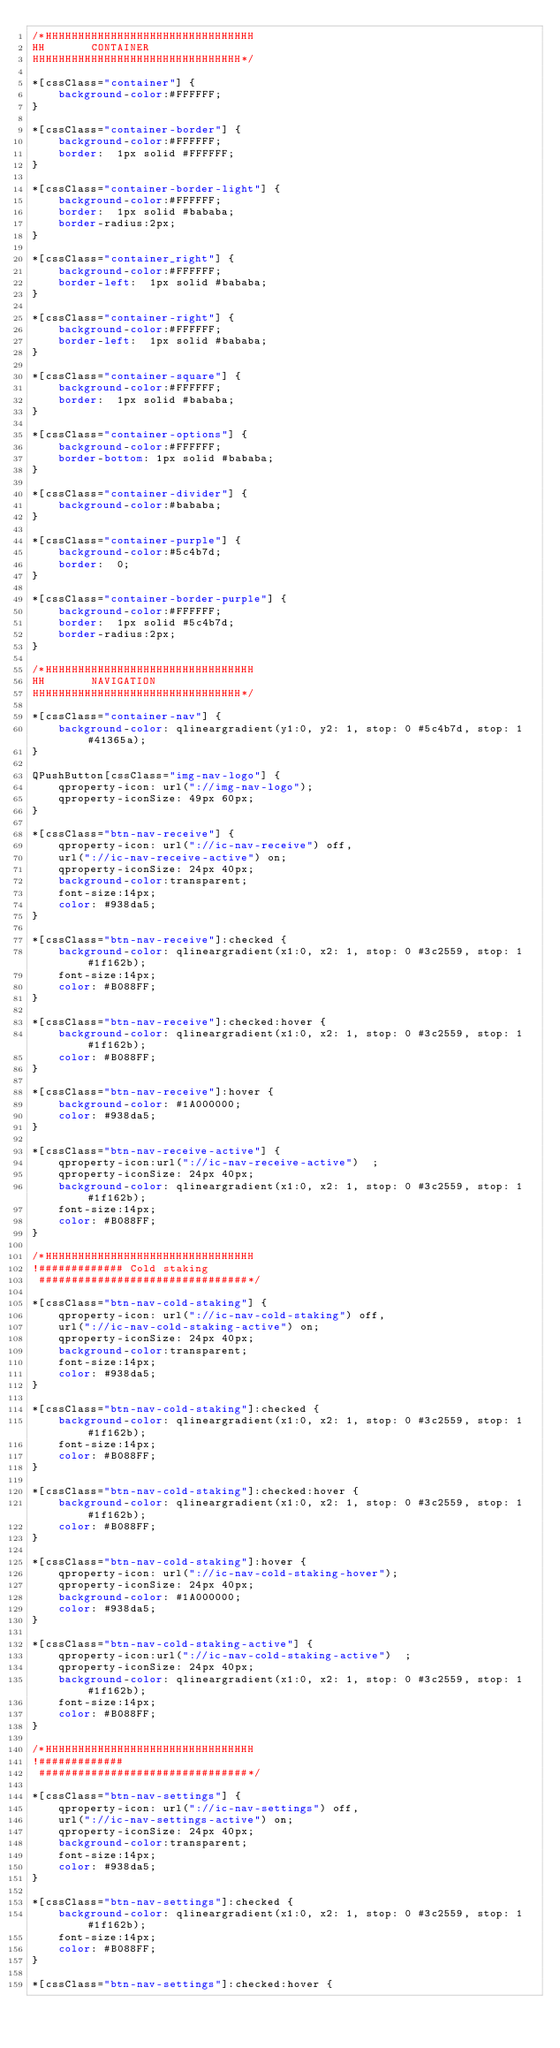<code> <loc_0><loc_0><loc_500><loc_500><_CSS_>/*HHHHHHHHHHHHHHHHHHHHHHHHHHHHHHHH
HH       CONTAINER
HHHHHHHHHHHHHHHHHHHHHHHHHHHHHHHH*/

*[cssClass="container"] {
    background-color:#FFFFFF;
}

*[cssClass="container-border"] {
    background-color:#FFFFFF;
    border:  1px solid #FFFFFF;
}

*[cssClass="container-border-light"] {
    background-color:#FFFFFF;
    border:  1px solid #bababa;
    border-radius:2px;
}

*[cssClass="container_right"] {
    background-color:#FFFFFF;
    border-left:  1px solid #bababa;
}

*[cssClass="container-right"] {
    background-color:#FFFFFF;
    border-left:  1px solid #bababa;
}

*[cssClass="container-square"] {
    background-color:#FFFFFF;
    border:  1px solid #bababa;
}

*[cssClass="container-options"] {
    background-color:#FFFFFF;
    border-bottom: 1px solid #bababa;
}

*[cssClass="container-divider"] {
    background-color:#bababa;
}

*[cssClass="container-purple"] {
    background-color:#5c4b7d;
    border:  0;
}

*[cssClass="container-border-purple"] {
    background-color:#FFFFFF;
    border:  1px solid #5c4b7d;
    border-radius:2px;
}

/*HHHHHHHHHHHHHHHHHHHHHHHHHHHHHHHH
HH       NAVIGATION
HHHHHHHHHHHHHHHHHHHHHHHHHHHHHHHH*/

*[cssClass="container-nav"] {
    background-color: qlineargradient(y1:0, y2: 1, stop: 0 #5c4b7d, stop: 1 #41365a);
}

QPushButton[cssClass="img-nav-logo"] {
    qproperty-icon: url("://img-nav-logo");
    qproperty-iconSize: 49px 60px;
}

*[cssClass="btn-nav-receive"] {
    qproperty-icon: url("://ic-nav-receive") off,
    url("://ic-nav-receive-active") on;
    qproperty-iconSize: 24px 40px;
    background-color:transparent;
    font-size:14px;
    color: #938da5;
}

*[cssClass="btn-nav-receive"]:checked {
    background-color: qlineargradient(x1:0, x2: 1, stop: 0 #3c2559, stop: 1 #1f162b);
    font-size:14px;
    color: #B088FF;
}

*[cssClass="btn-nav-receive"]:checked:hover {
    background-color: qlineargradient(x1:0, x2: 1, stop: 0 #3c2559, stop: 1 #1f162b);
    color: #B088FF;
}

*[cssClass="btn-nav-receive"]:hover {
    background-color: #1A000000;
    color: #938da5;
}

*[cssClass="btn-nav-receive-active"] {
    qproperty-icon:url("://ic-nav-receive-active")  ;
    qproperty-iconSize: 24px 40px;
    background-color: qlineargradient(x1:0, x2: 1, stop: 0 #3c2559, stop: 1 #1f162b);
    font-size:14px;
    color: #B088FF;
}

/*HHHHHHHHHHHHHHHHHHHHHHHHHHHHHHHH
!############# Cold staking
 ################################*/

*[cssClass="btn-nav-cold-staking"] {
    qproperty-icon: url("://ic-nav-cold-staking") off,
    url("://ic-nav-cold-staking-active") on;
    qproperty-iconSize: 24px 40px;
    background-color:transparent;
    font-size:14px;
    color: #938da5;
}

*[cssClass="btn-nav-cold-staking"]:checked {
    background-color: qlineargradient(x1:0, x2: 1, stop: 0 #3c2559, stop: 1 #1f162b);
    font-size:14px;
    color: #B088FF;
}

*[cssClass="btn-nav-cold-staking"]:checked:hover {
    background-color: qlineargradient(x1:0, x2: 1, stop: 0 #3c2559, stop: 1 #1f162b);
    color: #B088FF;
}

*[cssClass="btn-nav-cold-staking"]:hover {
    qproperty-icon: url("://ic-nav-cold-staking-hover");
    qproperty-iconSize: 24px 40px;
    background-color: #1A000000;
    color: #938da5;
}

*[cssClass="btn-nav-cold-staking-active"] {
    qproperty-icon:url("://ic-nav-cold-staking-active")  ;
    qproperty-iconSize: 24px 40px;
    background-color: qlineargradient(x1:0, x2: 1, stop: 0 #3c2559, stop: 1 #1f162b);
    font-size:14px;
    color: #B088FF;
}

/*HHHHHHHHHHHHHHHHHHHHHHHHHHHHHHHH
!#############
 ################################*/

*[cssClass="btn-nav-settings"] {
    qproperty-icon: url("://ic-nav-settings") off,
    url("://ic-nav-settings-active") on;
    qproperty-iconSize: 24px 40px;
    background-color:transparent;
    font-size:14px;
    color: #938da5;
}

*[cssClass="btn-nav-settings"]:checked {
    background-color: qlineargradient(x1:0, x2: 1, stop: 0 #3c2559, stop: 1 #1f162b);
    font-size:14px;
    color: #B088FF;
}

*[cssClass="btn-nav-settings"]:checked:hover {</code> 